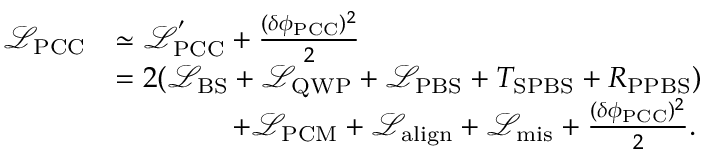<formula> <loc_0><loc_0><loc_500><loc_500>\begin{array} { r l } { \mathcal { L } _ { P C C } } & { \simeq \mathcal { L } _ { P C C } ^ { ^ { \prime } } + \frac { ( \delta \phi _ { P C C } ) ^ { 2 } } { 2 } } \\ & { = 2 ( \mathcal { L } _ { B S } + \mathcal { L } _ { Q W P } + \mathcal { L } _ { P B S } + T _ { S P B S } + R _ { P P B S } ) } \\ & { \quad + \mathcal { L } _ { P C M } + \mathcal { L } _ { a l i g n } + \mathcal { L } _ { m i s } + \frac { ( \delta \phi _ { P C C } ) ^ { 2 } } { 2 } . } \end{array}</formula> 